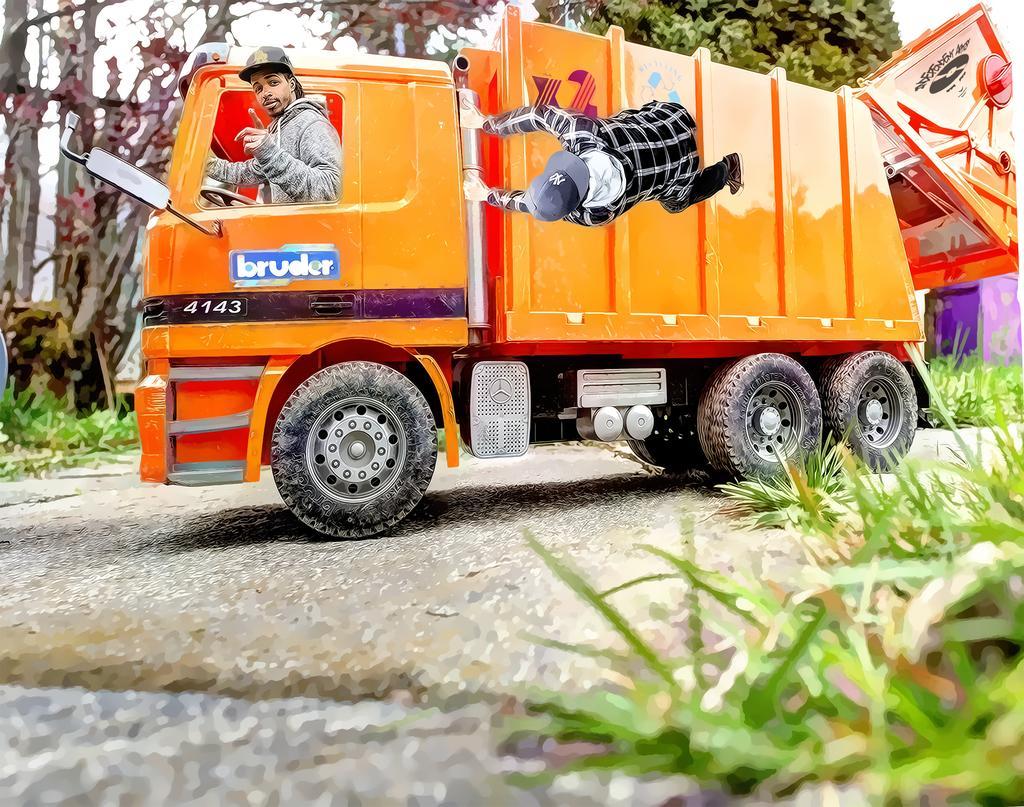Please provide a concise description of this image. In this image we can see a vehicle. There are trees and plants. Also there are persons. And there is photo effect on the image. 